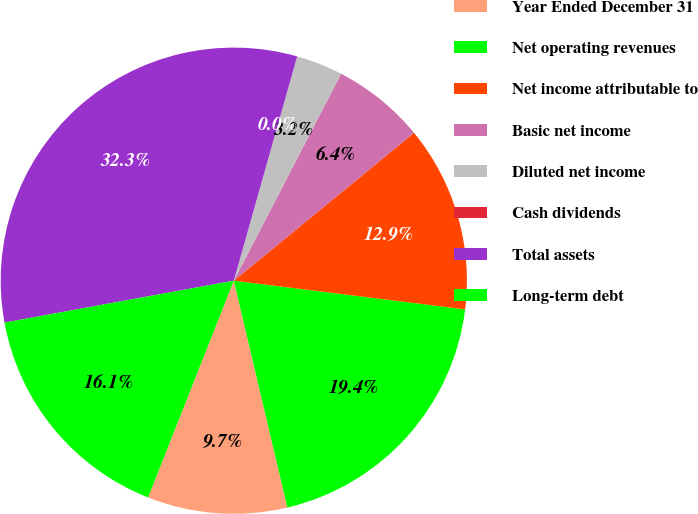<chart> <loc_0><loc_0><loc_500><loc_500><pie_chart><fcel>Year Ended December 31<fcel>Net operating revenues<fcel>Net income attributable to<fcel>Basic net income<fcel>Diluted net income<fcel>Cash dividends<fcel>Total assets<fcel>Long-term debt<nl><fcel>9.68%<fcel>19.35%<fcel>12.9%<fcel>6.45%<fcel>3.23%<fcel>0.0%<fcel>32.26%<fcel>16.13%<nl></chart> 